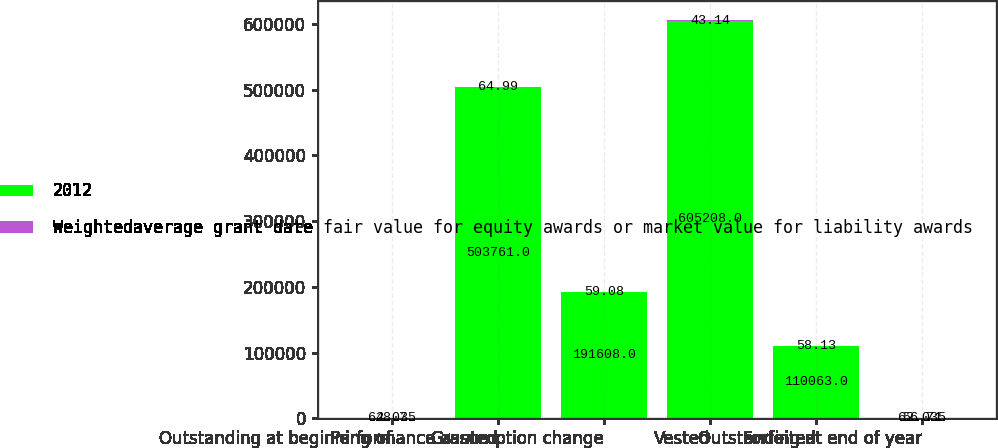Convert chart to OTSL. <chart><loc_0><loc_0><loc_500><loc_500><stacked_bar_chart><ecel><fcel>Outstanding at beginning of<fcel>Granted<fcel>Performance assumption change<fcel>Vested<fcel>Forfeited<fcel>Outstanding at end of year<nl><fcel>2012<fcel>62.035<fcel>503761<fcel>191608<fcel>605208<fcel>110063<fcel>62.035<nl><fcel>Weightedaverage grant date fair value for equity awards or market value for liability awards<fcel>48.7<fcel>64.99<fcel>59.08<fcel>43.14<fcel>58.13<fcel>56.71<nl></chart> 